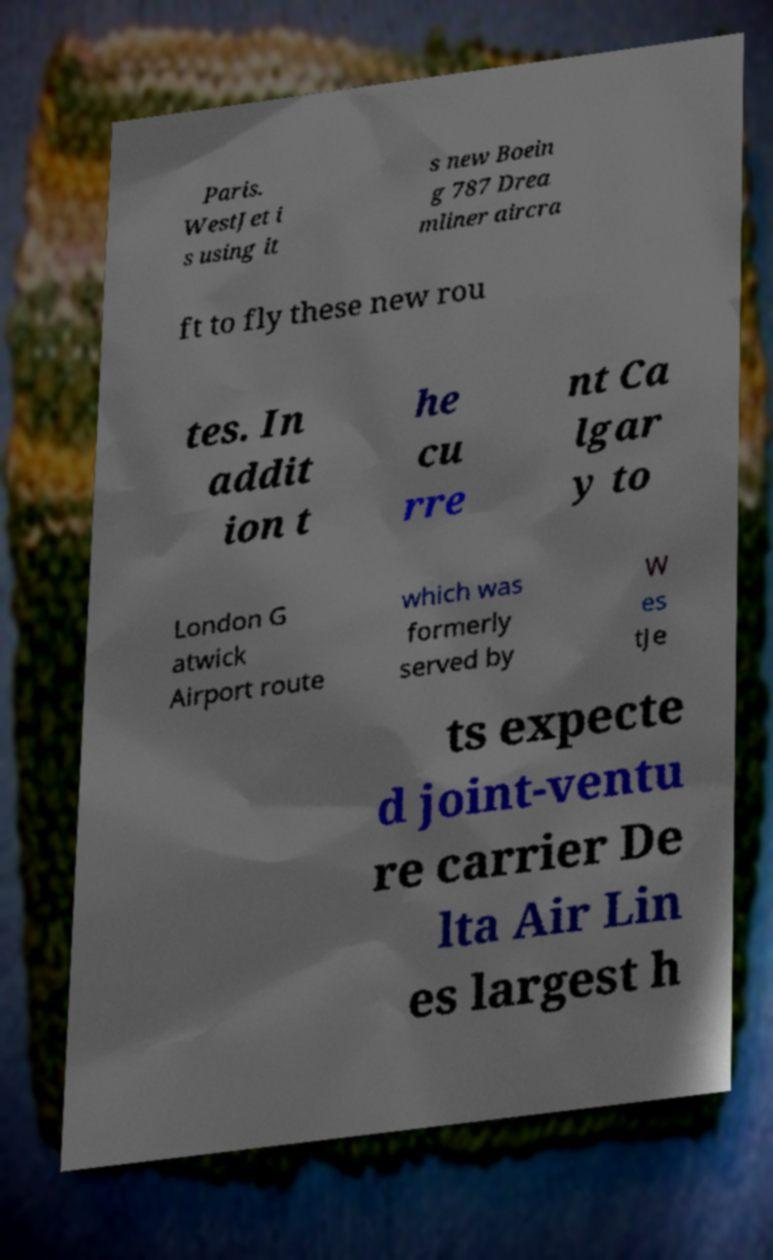For documentation purposes, I need the text within this image transcribed. Could you provide that? Paris. WestJet i s using it s new Boein g 787 Drea mliner aircra ft to fly these new rou tes. In addit ion t he cu rre nt Ca lgar y to London G atwick Airport route which was formerly served by W es tJe ts expecte d joint-ventu re carrier De lta Air Lin es largest h 